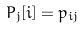<formula> <loc_0><loc_0><loc_500><loc_500>P _ { j } [ i ] = p _ { i j }</formula> 